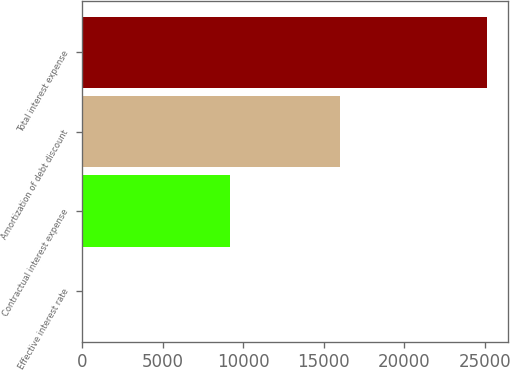Convert chart to OTSL. <chart><loc_0><loc_0><loc_500><loc_500><bar_chart><fcel>Effective interest rate<fcel>Contractual interest expense<fcel>Amortization of debt discount<fcel>Total interest expense<nl><fcel>8.1<fcel>9157<fcel>16007<fcel>25164<nl></chart> 